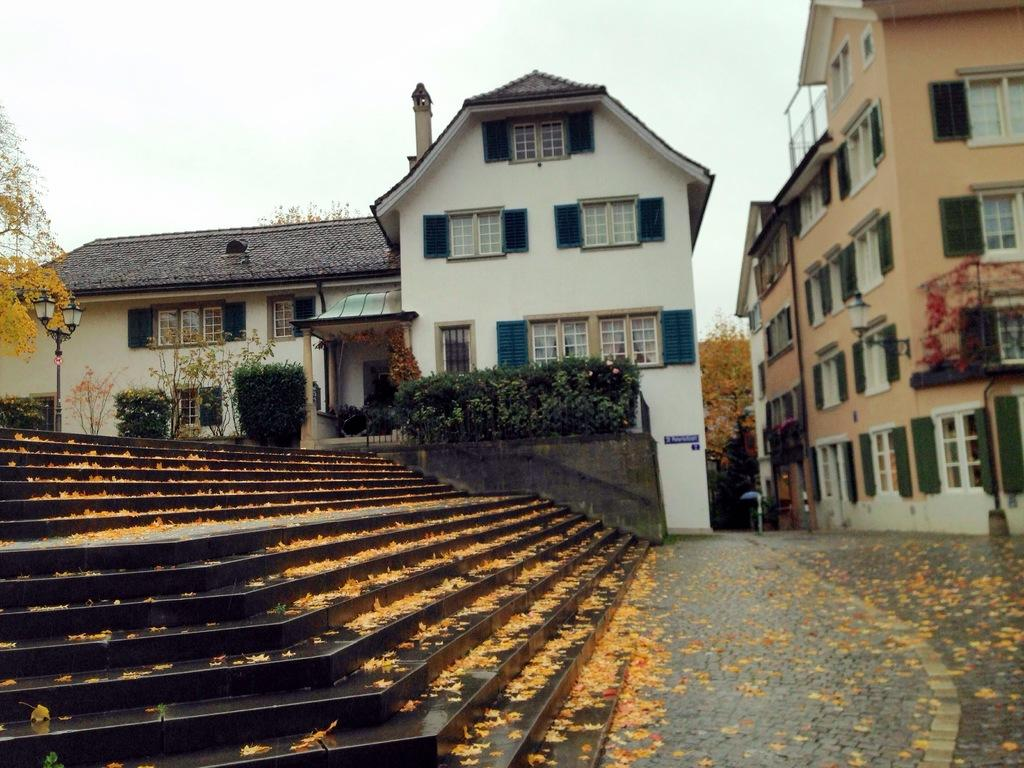What type of structure can be seen in the image? There are stairs, trees, plants, buildings, and windows visible in the image. What type of vegetation is present in the image? There are trees and plants in the image. What is visible in the background of the image? The sky is visible in the image. What type of sugar is being used to decorate the trees in the image? There is no sugar present in the image, and the trees are not decorated. What season is depicted in the image, considering the presence of winter clothing? There is no indication of winter clothing or any specific season in the image. 